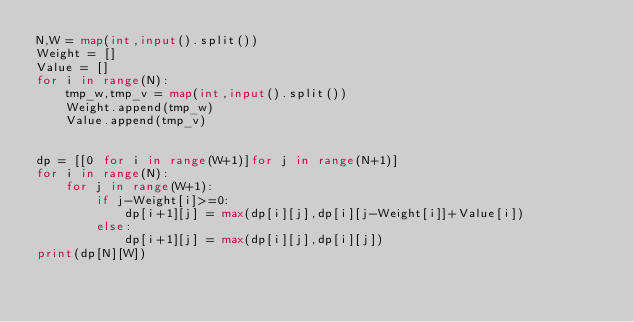<code> <loc_0><loc_0><loc_500><loc_500><_Python_>N,W = map(int,input().split())
Weight = []
Value = []
for i in range(N):
    tmp_w,tmp_v = map(int,input().split())
    Weight.append(tmp_w)
    Value.append(tmp_v)


dp = [[0 for i in range(W+1)]for j in range(N+1)]
for i in range(N):
    for j in range(W+1):
        if j-Weight[i]>=0:
            dp[i+1][j] = max(dp[i][j],dp[i][j-Weight[i]]+Value[i])
        else:
            dp[i+1][j] = max(dp[i][j],dp[i][j])
print(dp[N][W])
</code> 